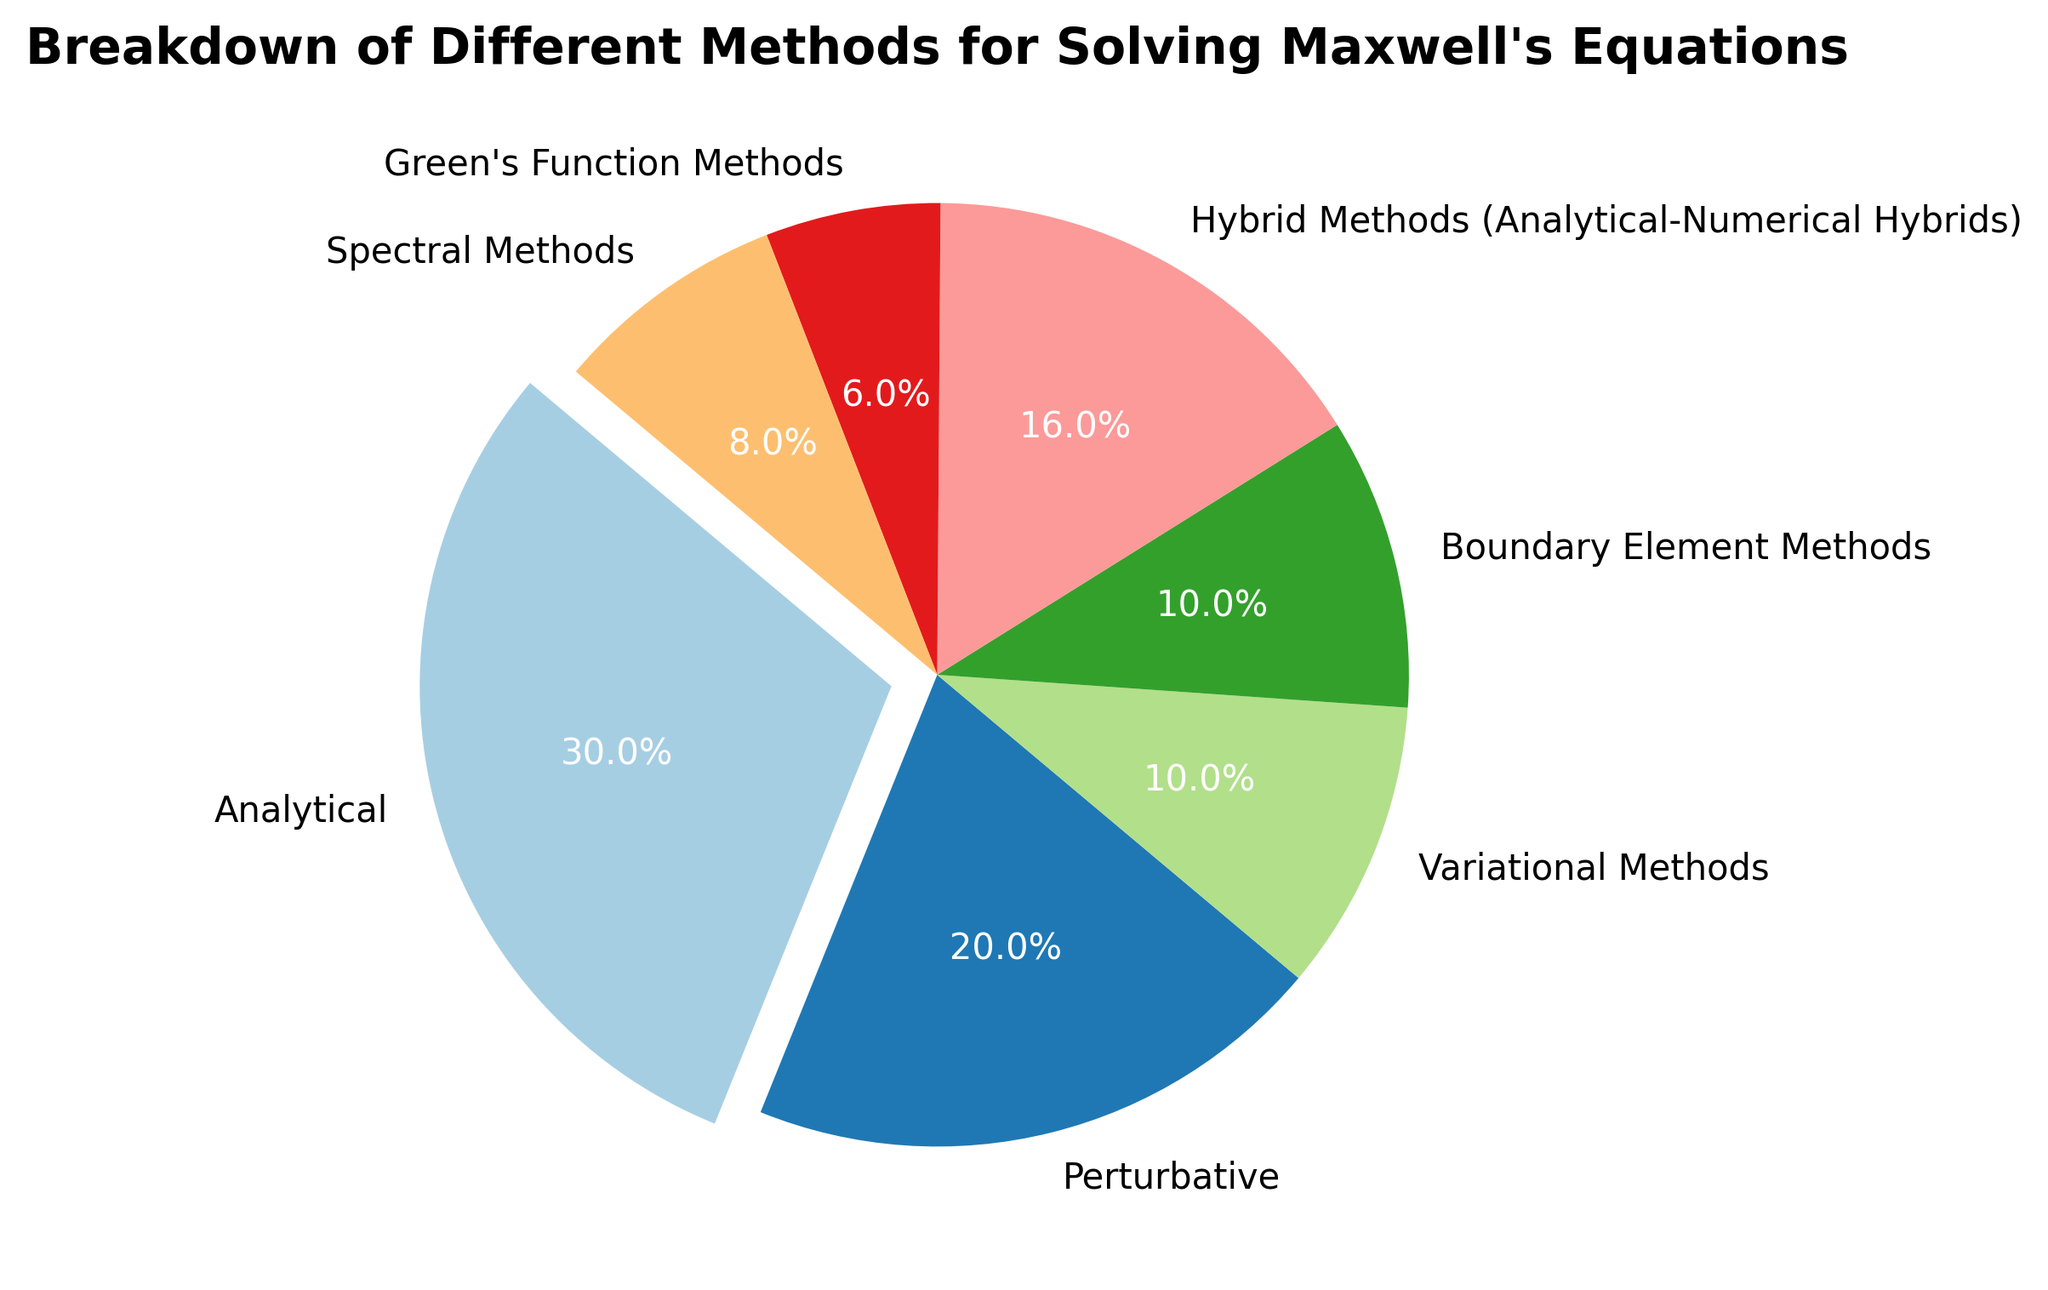Which method has the largest percentage in the breakdown of methods for solving Maxwell's Equations? Looking at the pie chart and observing the exploded slice, it indicates the method with the maximum percentage. The exploded slice corresponds to the 'Analytical' method.
Answer: Analytical Which two methods together account for exactly 10% of the total percentage? The pie chart labels show the percentages for each method. 'Boundary Element Methods' and 'Variational Methods' each have 5%, summing up to 10%.
Answer: Boundary Element Methods and Variational Methods What is the total percentage represented by the methods 'Variational Methods,' 'Spectral Methods,' and 'Green's Function Methods'? By summing up the percentages of these three methods (5% + 4% + 3%), we get the total percentage.
Answer: 12% Which method has a smaller percentage than 'Perturbative' but larger than 'Spectral Methods'? Observing the pie chart and comparing the sections corresponding to 'Perturbative' (10%) and 'Spectral Methods' (4%), 'Hybrid Methods (Analytical-Numerical Hybrids)' with 8% fits the criteria.
Answer: Hybrid Methods (Analytical-Numerical Hybrids) What is the difference in percentage between the 'Analytical' method and the 'Perturbative' method? By subtracting the percentage of 'Perturbative' (10%) from that of 'Analytical' (15%), the difference is found.
Answer: 5% Which methods have an equal percentage of representation? Observing the pie chart, both the 'Boundary Element Methods' and 'Variational Methods' have a representation of 5%.
Answer: Boundary Element Methods and Variational Methods What is the combined percentage of the top three methods in terms of their representation? Adding the percentages of the top three methods ('Analytical' 15%, 'Perturbative' 10%, and 'Hybrid Methods' 8%), the total is obtained.
Answer: 33% Among the methods listed, which one has the least representation? Looking at the pie chart, the smallest percentage is shown for 'Green's Function Methods', which is 3%.
Answer: Green's Function Methods Which methods together account for more than half of the total percentage? Summing the percentages of 'Analytical' (15%), 'Perturbative' (10%), and 'Hybrid Methods' (8%), we get 33%. Including 'Boundary Element Methods' and 'Variational Methods', each at 5%, adds up to 43%. Adding 'Spectral Methods' (4%) results in 47%, and including 'Green's Function Methods' (3%) reaches 50%. All methods together or combinations that do not include all methods will not exceed 50%.
Answer: All methods 